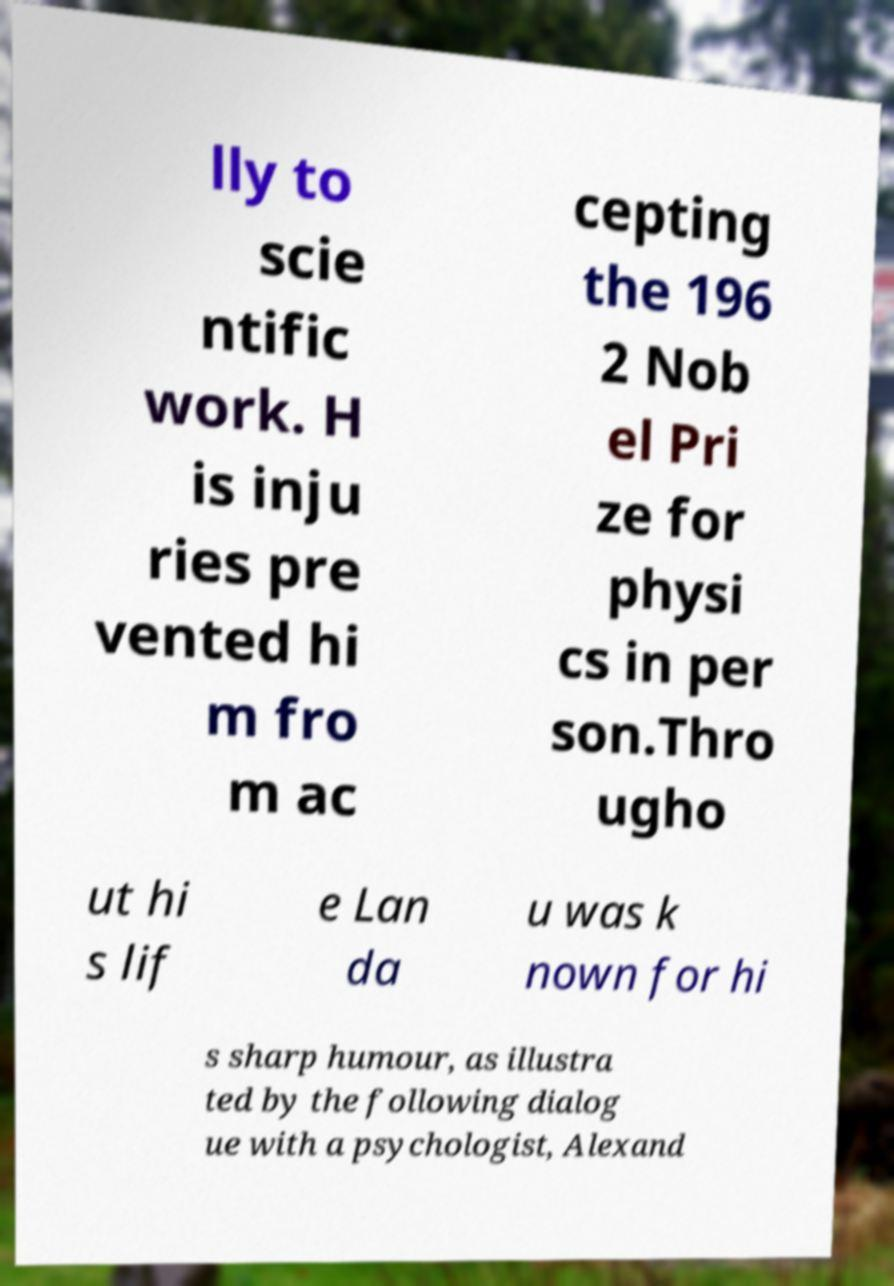What messages or text are displayed in this image? I need them in a readable, typed format. lly to scie ntific work. H is inju ries pre vented hi m fro m ac cepting the 196 2 Nob el Pri ze for physi cs in per son.Thro ugho ut hi s lif e Lan da u was k nown for hi s sharp humour, as illustra ted by the following dialog ue with a psychologist, Alexand 